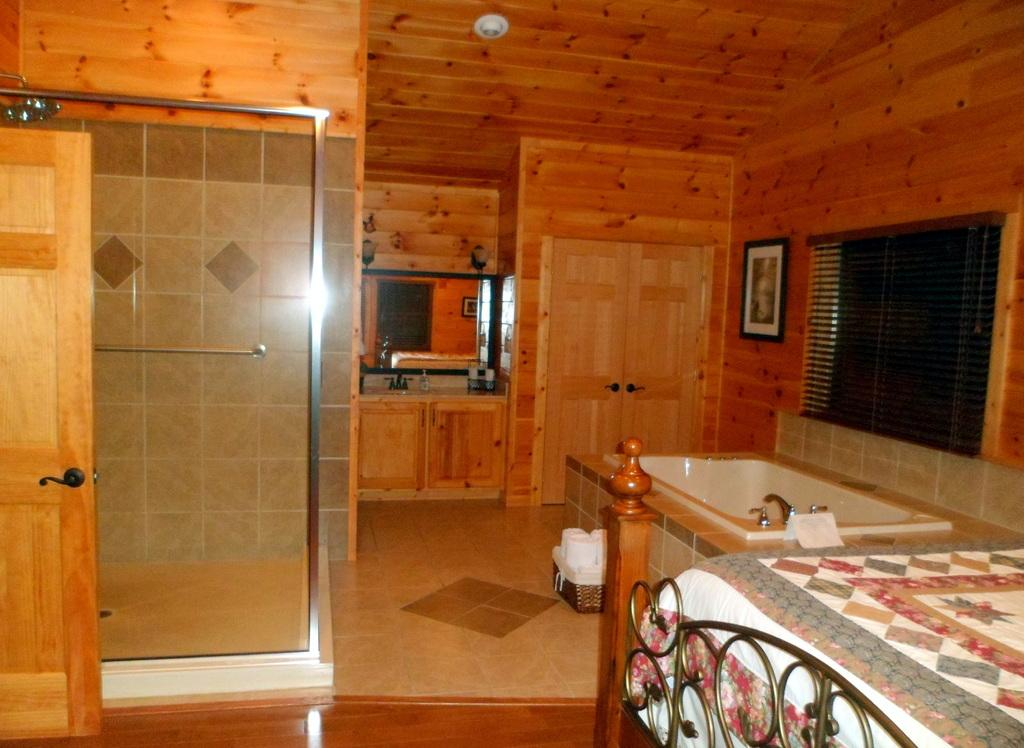What type of space is depicted in the image? There is a room in the image. What furniture or fixtures can be seen in the room? There is a bed and a bathtub in the room. Are there any reflective surfaces in the room? Yes, there is a mirror attached to the wall in the room. How can natural light enter the room? There is a window in the room. Is there a way to enter or exit the room? Yes, there is a door in the room. How many horses are visible in the image? There are no horses present in the image. Are there any apples on the bed in the image? There is no mention of apples in the image, and they are not visible in the provided facts. 